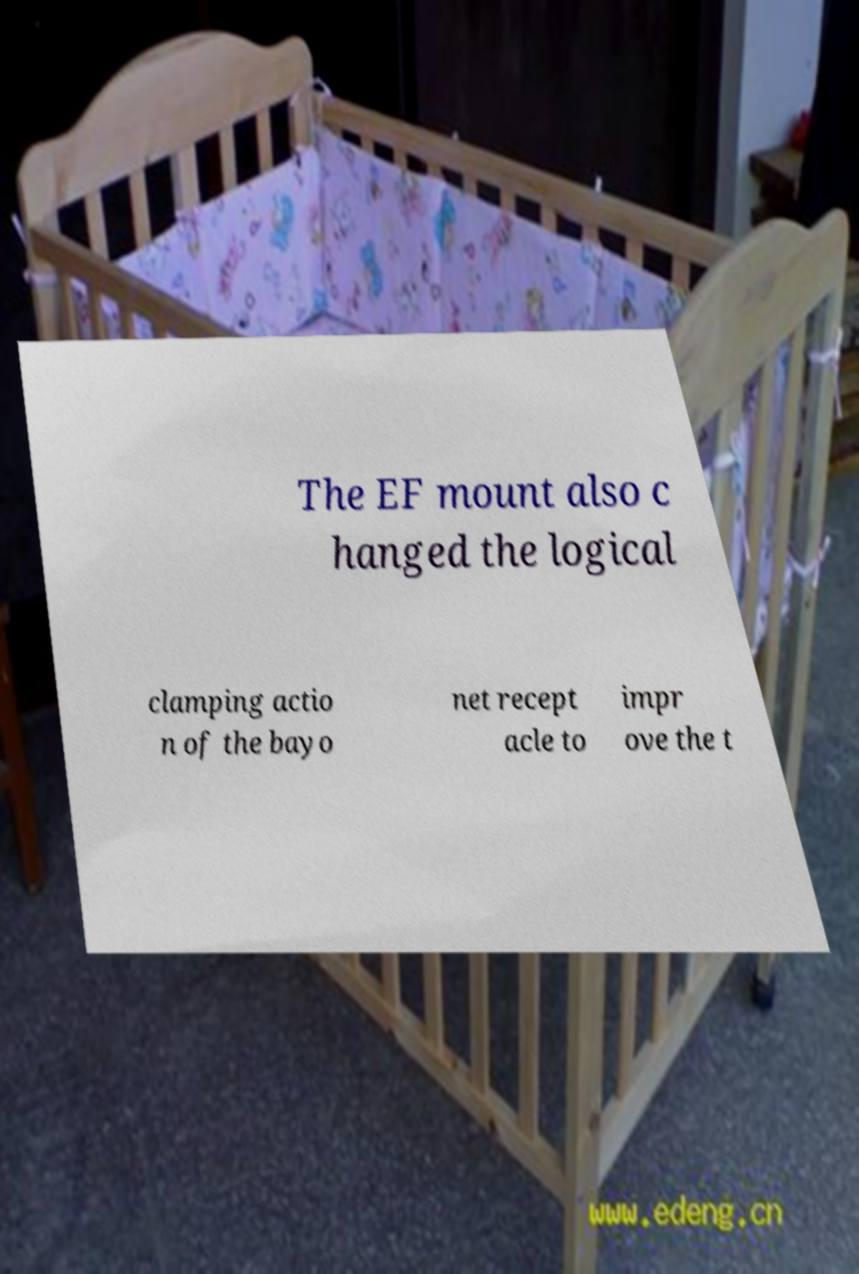Please identify and transcribe the text found in this image. The EF mount also c hanged the logical clamping actio n of the bayo net recept acle to impr ove the t 